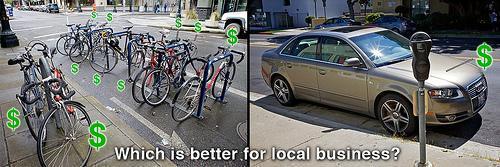How many price tags are on the right picture?
Give a very brief answer. 1. 